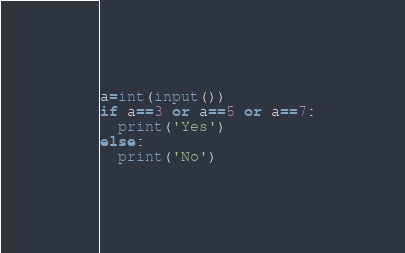Convert code to text. <code><loc_0><loc_0><loc_500><loc_500><_Python_>a=int(input())
if a==3 or a==5 or a==7:
  print('Yes')
else:
  print('No')</code> 